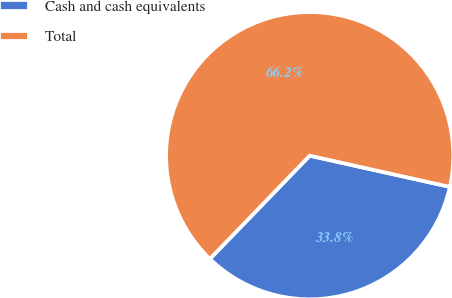Convert chart. <chart><loc_0><loc_0><loc_500><loc_500><pie_chart><fcel>Cash and cash equivalents<fcel>Total<nl><fcel>33.75%<fcel>66.25%<nl></chart> 